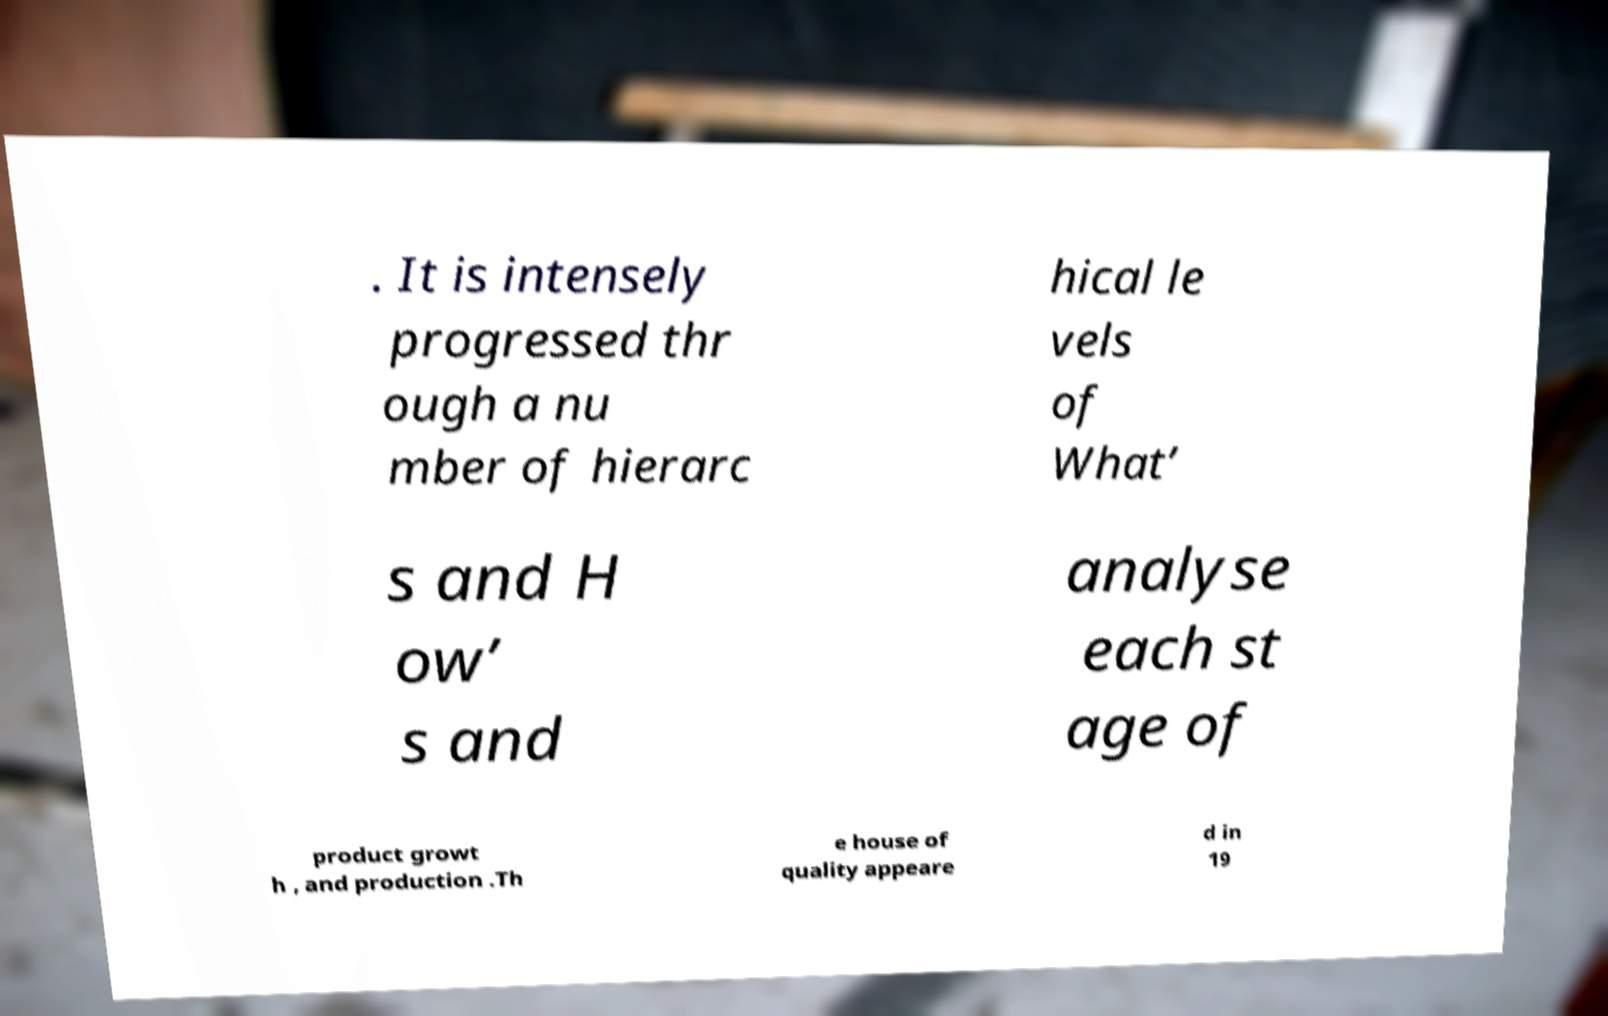There's text embedded in this image that I need extracted. Can you transcribe it verbatim? . It is intensely progressed thr ough a nu mber of hierarc hical le vels of What’ s and H ow’ s and analyse each st age of product growt h , and production .Th e house of quality appeare d in 19 